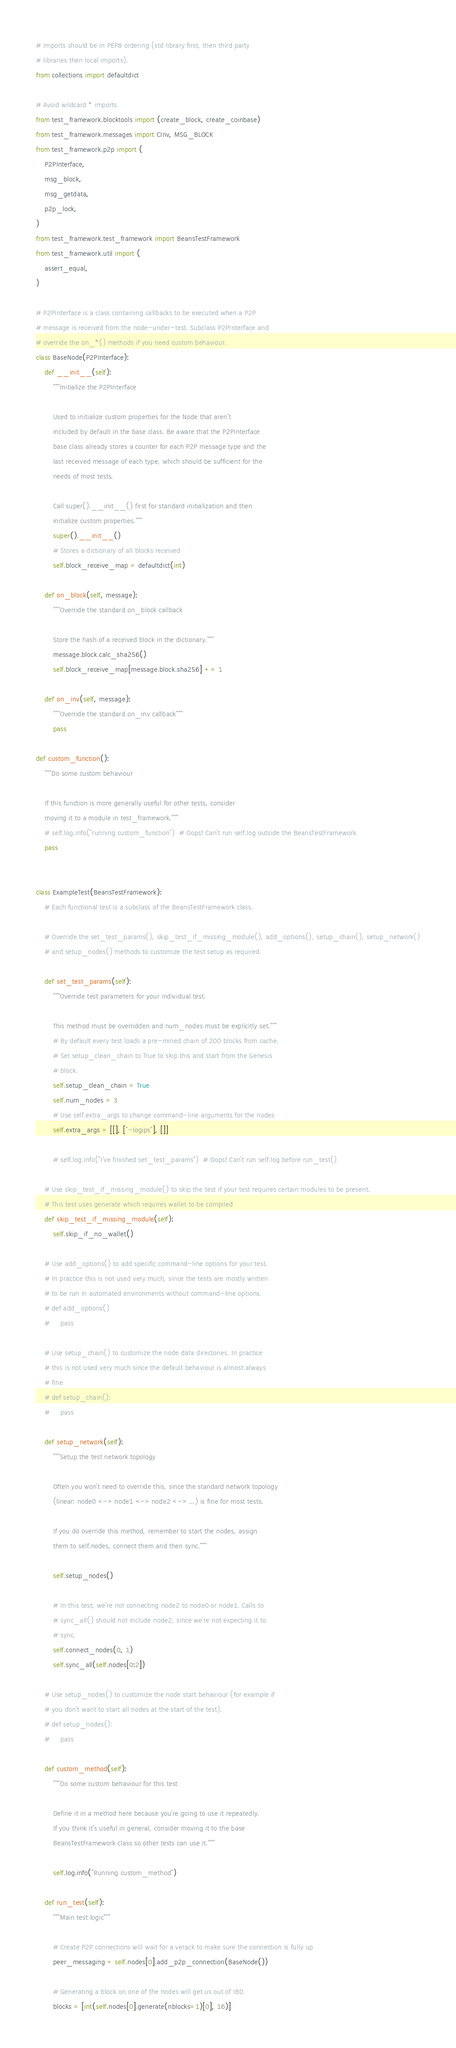<code> <loc_0><loc_0><loc_500><loc_500><_Python_># Imports should be in PEP8 ordering (std library first, then third party
# libraries then local imports).
from collections import defaultdict

# Avoid wildcard * imports
from test_framework.blocktools import (create_block, create_coinbase)
from test_framework.messages import CInv, MSG_BLOCK
from test_framework.p2p import (
    P2PInterface,
    msg_block,
    msg_getdata,
    p2p_lock,
)
from test_framework.test_framework import BeansTestFramework
from test_framework.util import (
    assert_equal,
)

# P2PInterface is a class containing callbacks to be executed when a P2P
# message is received from the node-under-test. Subclass P2PInterface and
# override the on_*() methods if you need custom behaviour.
class BaseNode(P2PInterface):
    def __init__(self):
        """Initialize the P2PInterface

        Used to initialize custom properties for the Node that aren't
        included by default in the base class. Be aware that the P2PInterface
        base class already stores a counter for each P2P message type and the
        last received message of each type, which should be sufficient for the
        needs of most tests.

        Call super().__init__() first for standard initialization and then
        initialize custom properties."""
        super().__init__()
        # Stores a dictionary of all blocks received
        self.block_receive_map = defaultdict(int)

    def on_block(self, message):
        """Override the standard on_block callback

        Store the hash of a received block in the dictionary."""
        message.block.calc_sha256()
        self.block_receive_map[message.block.sha256] += 1

    def on_inv(self, message):
        """Override the standard on_inv callback"""
        pass

def custom_function():
    """Do some custom behaviour

    If this function is more generally useful for other tests, consider
    moving it to a module in test_framework."""
    # self.log.info("running custom_function")  # Oops! Can't run self.log outside the BeansTestFramework
    pass


class ExampleTest(BeansTestFramework):
    # Each functional test is a subclass of the BeansTestFramework class.

    # Override the set_test_params(), skip_test_if_missing_module(), add_options(), setup_chain(), setup_network()
    # and setup_nodes() methods to customize the test setup as required.

    def set_test_params(self):
        """Override test parameters for your individual test.

        This method must be overridden and num_nodes must be explicitly set."""
        # By default every test loads a pre-mined chain of 200 blocks from cache.
        # Set setup_clean_chain to True to skip this and start from the Genesis
        # block.
        self.setup_clean_chain = True
        self.num_nodes = 3
        # Use self.extra_args to change command-line arguments for the nodes
        self.extra_args = [[], ["-logips"], []]

        # self.log.info("I've finished set_test_params")  # Oops! Can't run self.log before run_test()

    # Use skip_test_if_missing_module() to skip the test if your test requires certain modules to be present.
    # This test uses generate which requires wallet to be compiled
    def skip_test_if_missing_module(self):
        self.skip_if_no_wallet()

    # Use add_options() to add specific command-line options for your test.
    # In practice this is not used very much, since the tests are mostly written
    # to be run in automated environments without command-line options.
    # def add_options()
    #     pass

    # Use setup_chain() to customize the node data directories. In practice
    # this is not used very much since the default behaviour is almost always
    # fine
    # def setup_chain():
    #     pass

    def setup_network(self):
        """Setup the test network topology

        Often you won't need to override this, since the standard network topology
        (linear: node0 <-> node1 <-> node2 <-> ...) is fine for most tests.

        If you do override this method, remember to start the nodes, assign
        them to self.nodes, connect them and then sync."""

        self.setup_nodes()

        # In this test, we're not connecting node2 to node0 or node1. Calls to
        # sync_all() should not include node2, since we're not expecting it to
        # sync.
        self.connect_nodes(0, 1)
        self.sync_all(self.nodes[0:2])

    # Use setup_nodes() to customize the node start behaviour (for example if
    # you don't want to start all nodes at the start of the test).
    # def setup_nodes():
    #     pass

    def custom_method(self):
        """Do some custom behaviour for this test

        Define it in a method here because you're going to use it repeatedly.
        If you think it's useful in general, consider moving it to the base
        BeansTestFramework class so other tests can use it."""

        self.log.info("Running custom_method")

    def run_test(self):
        """Main test logic"""

        # Create P2P connections will wait for a verack to make sure the connection is fully up
        peer_messaging = self.nodes[0].add_p2p_connection(BaseNode())

        # Generating a block on one of the nodes will get us out of IBD
        blocks = [int(self.nodes[0].generate(nblocks=1)[0], 16)]</code> 